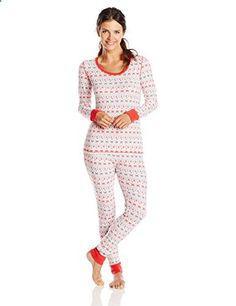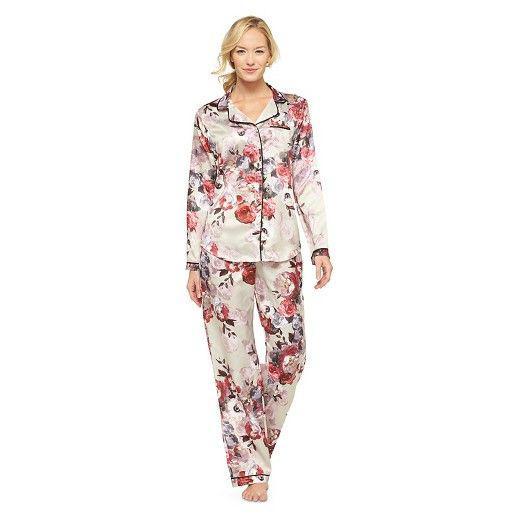The first image is the image on the left, the second image is the image on the right. Evaluate the accuracy of this statement regarding the images: "There is one woman wearing tight fitting pajamas, and one woman wearing more loose fitting pajamas.". Is it true? Answer yes or no. Yes. The first image is the image on the left, the second image is the image on the right. Assess this claim about the two images: "The female in the right image is standing with her feet crossed.". Correct or not? Answer yes or no. Yes. 